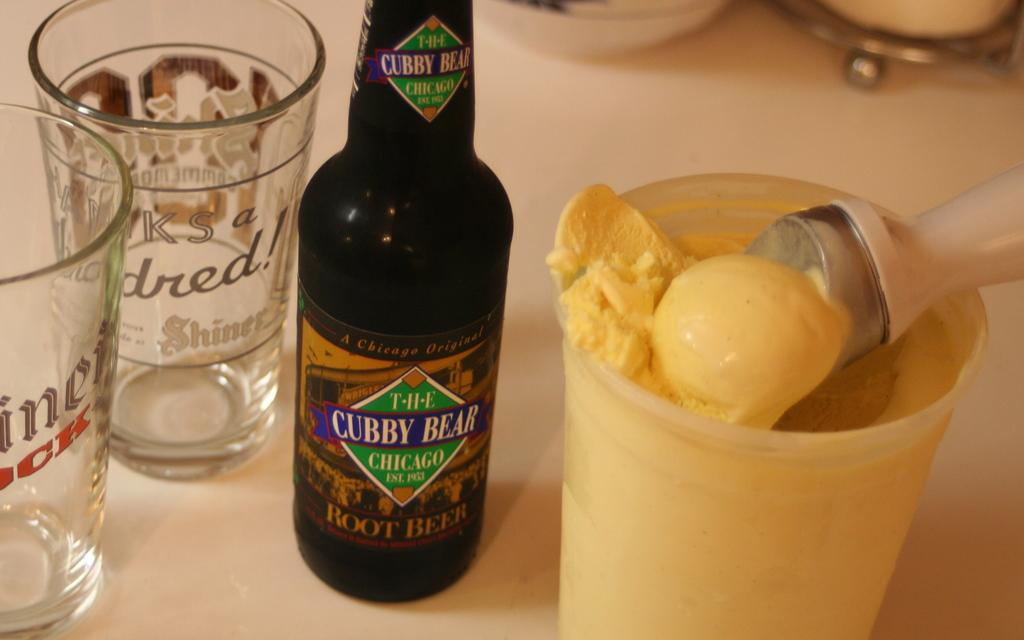<image>
Share a concise interpretation of the image provided. A black bottle of Cubby Bear beer sitting next to a bowl of vanilla ice cream. 